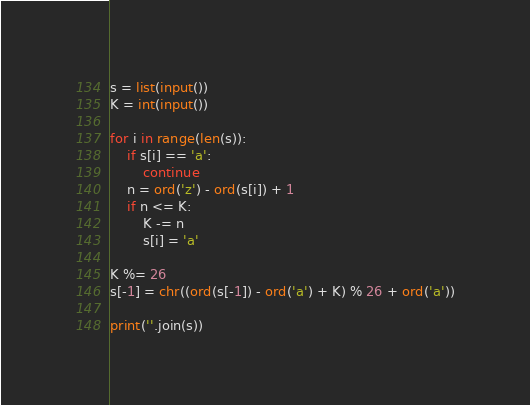<code> <loc_0><loc_0><loc_500><loc_500><_Python_>s = list(input())
K = int(input())

for i in range(len(s)):
    if s[i] == 'a':
        continue
    n = ord('z') - ord(s[i]) + 1
    if n <= K:
        K -= n
        s[i] = 'a'

K %= 26
s[-1] = chr((ord(s[-1]) - ord('a') + K) % 26 + ord('a'))

print(''.join(s))
</code> 